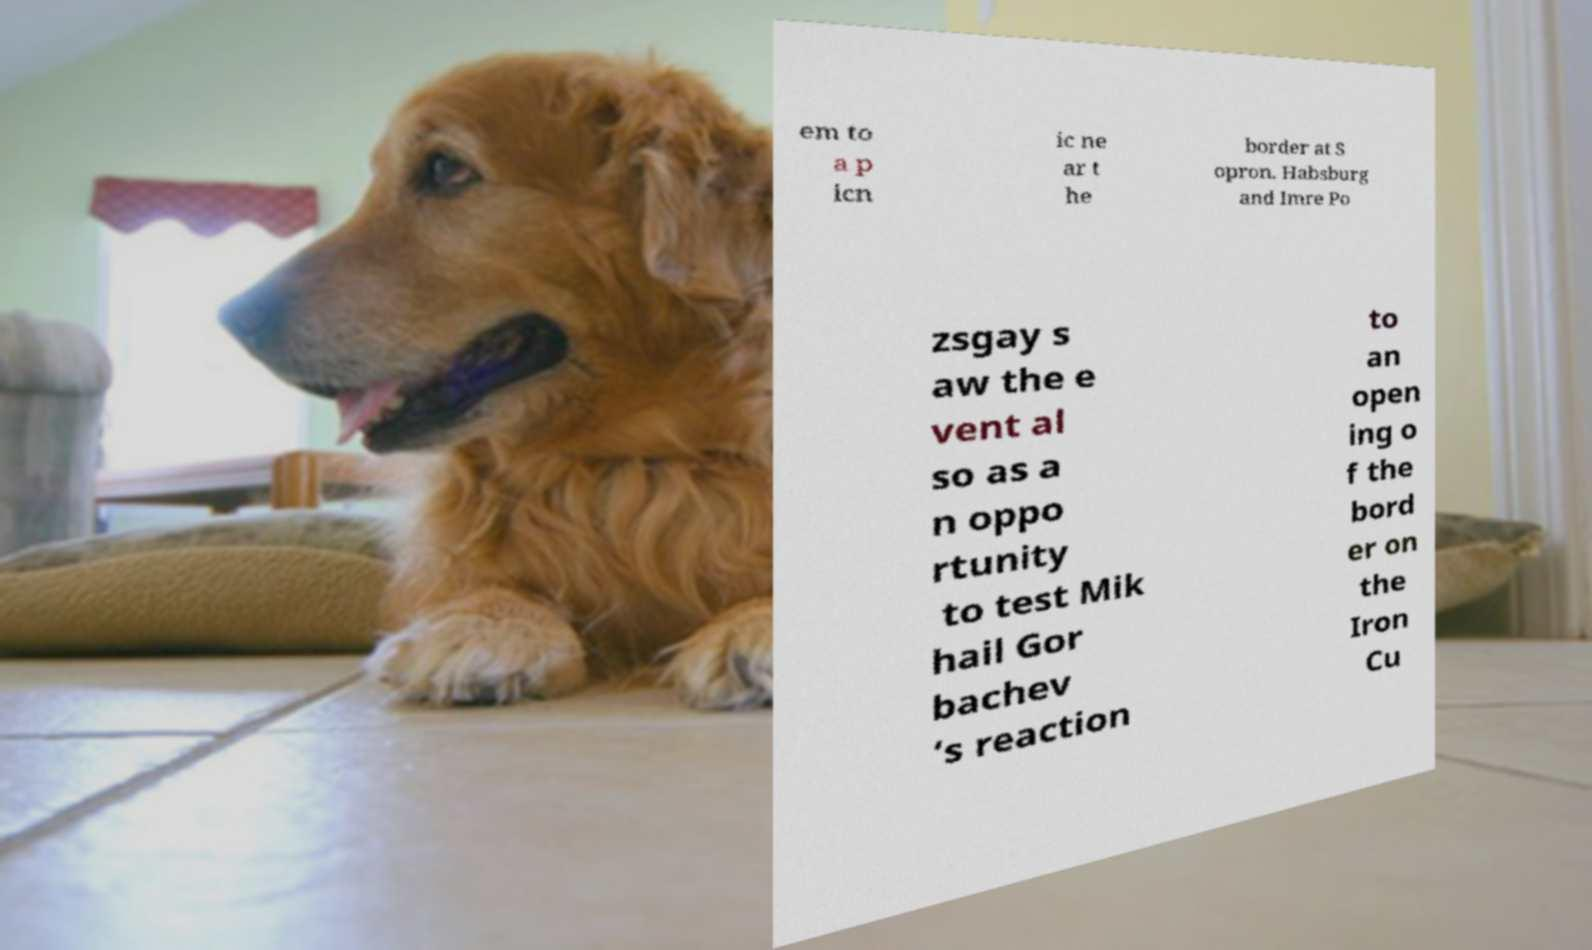Could you assist in decoding the text presented in this image and type it out clearly? em to a p icn ic ne ar t he border at S opron. Habsburg and Imre Po zsgay s aw the e vent al so as a n oppo rtunity to test Mik hail Gor bachev ’s reaction to an open ing o f the bord er on the Iron Cu 